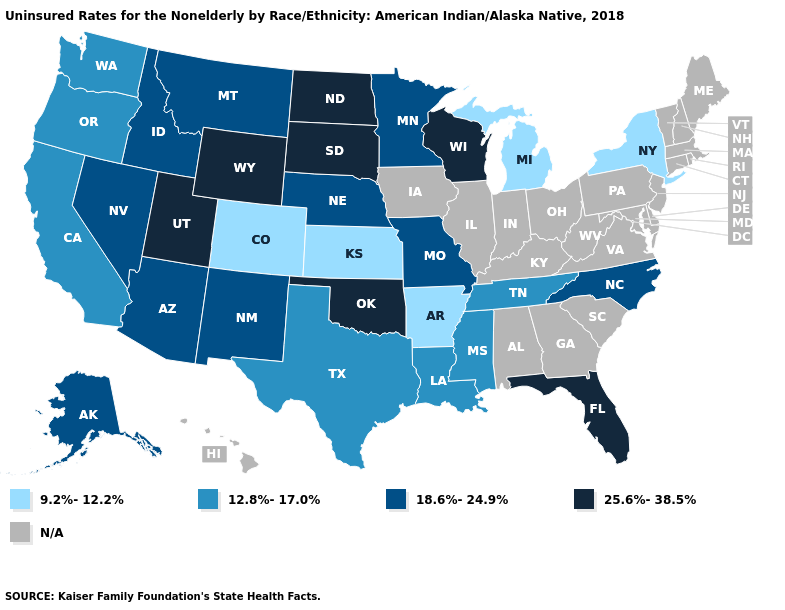What is the highest value in the USA?
Write a very short answer. 25.6%-38.5%. Name the states that have a value in the range 12.8%-17.0%?
Give a very brief answer. California, Louisiana, Mississippi, Oregon, Tennessee, Texas, Washington. What is the value of Nebraska?
Be succinct. 18.6%-24.9%. What is the lowest value in states that border New Mexico?
Keep it brief. 9.2%-12.2%. Name the states that have a value in the range 25.6%-38.5%?
Concise answer only. Florida, North Dakota, Oklahoma, South Dakota, Utah, Wisconsin, Wyoming. What is the value of Colorado?
Quick response, please. 9.2%-12.2%. Does North Dakota have the highest value in the USA?
Give a very brief answer. Yes. Name the states that have a value in the range N/A?
Be succinct. Alabama, Connecticut, Delaware, Georgia, Hawaii, Illinois, Indiana, Iowa, Kentucky, Maine, Maryland, Massachusetts, New Hampshire, New Jersey, Ohio, Pennsylvania, Rhode Island, South Carolina, Vermont, Virginia, West Virginia. Name the states that have a value in the range 12.8%-17.0%?
Be succinct. California, Louisiana, Mississippi, Oregon, Tennessee, Texas, Washington. Name the states that have a value in the range 18.6%-24.9%?
Give a very brief answer. Alaska, Arizona, Idaho, Minnesota, Missouri, Montana, Nebraska, Nevada, New Mexico, North Carolina. What is the highest value in states that border Montana?
Be succinct. 25.6%-38.5%. What is the value of Maryland?
Keep it brief. N/A. Does the map have missing data?
Quick response, please. Yes. 